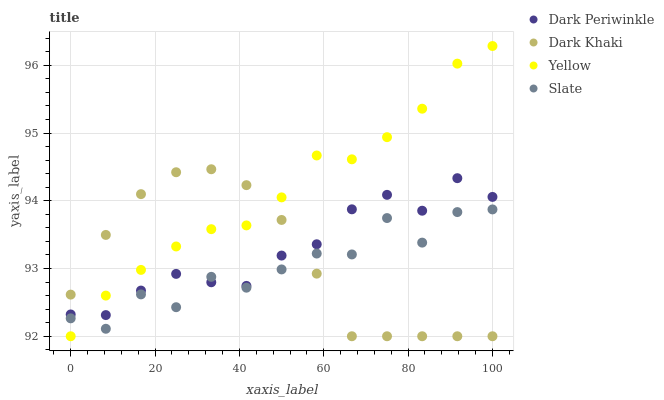Does Slate have the minimum area under the curve?
Answer yes or no. Yes. Does Yellow have the maximum area under the curve?
Answer yes or no. Yes. Does Dark Periwinkle have the minimum area under the curve?
Answer yes or no. No. Does Dark Periwinkle have the maximum area under the curve?
Answer yes or no. No. Is Dark Khaki the smoothest?
Answer yes or no. Yes. Is Slate the roughest?
Answer yes or no. Yes. Is Dark Periwinkle the smoothest?
Answer yes or no. No. Is Dark Periwinkle the roughest?
Answer yes or no. No. Does Dark Khaki have the lowest value?
Answer yes or no. Yes. Does Slate have the lowest value?
Answer yes or no. No. Does Yellow have the highest value?
Answer yes or no. Yes. Does Dark Periwinkle have the highest value?
Answer yes or no. No. Does Dark Periwinkle intersect Yellow?
Answer yes or no. Yes. Is Dark Periwinkle less than Yellow?
Answer yes or no. No. Is Dark Periwinkle greater than Yellow?
Answer yes or no. No. 